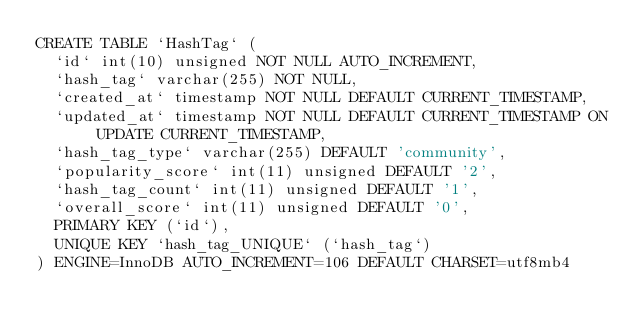Convert code to text. <code><loc_0><loc_0><loc_500><loc_500><_SQL_>CREATE TABLE `HashTag` (
  `id` int(10) unsigned NOT NULL AUTO_INCREMENT,
  `hash_tag` varchar(255) NOT NULL,
  `created_at` timestamp NOT NULL DEFAULT CURRENT_TIMESTAMP,
  `updated_at` timestamp NOT NULL DEFAULT CURRENT_TIMESTAMP ON UPDATE CURRENT_TIMESTAMP,
  `hash_tag_type` varchar(255) DEFAULT 'community',
  `popularity_score` int(11) unsigned DEFAULT '2',
  `hash_tag_count` int(11) unsigned DEFAULT '1',
  `overall_score` int(11) unsigned DEFAULT '0',
  PRIMARY KEY (`id`),
  UNIQUE KEY `hash_tag_UNIQUE` (`hash_tag`)
) ENGINE=InnoDB AUTO_INCREMENT=106 DEFAULT CHARSET=utf8mb4
</code> 